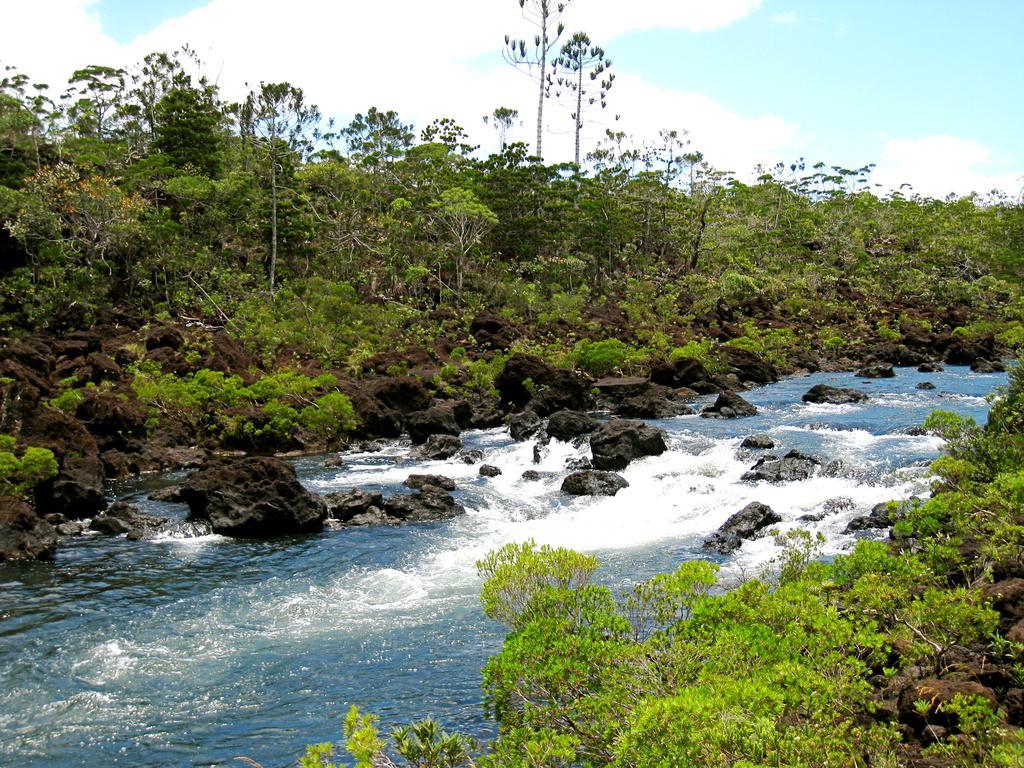How would you summarize this image in a sentence or two? Here in this picture in the middle we can see water flowing through a place, as we can see rock stones present all over there and on the either sides we can see plants and trees present all over there and we can also see clouds in the sky. 